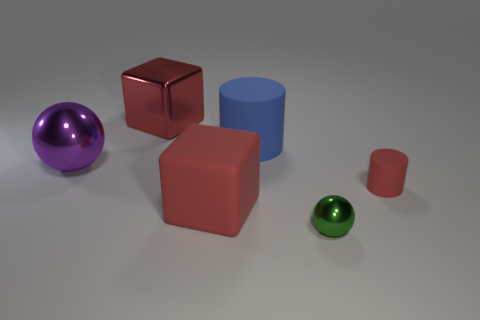Can you compare the size of the blue cylinder to that of the red cube? Certainly, the blue cylinder is taller but has a smaller diameter when compared to the width and height of the red cube. 